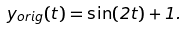<formula> <loc_0><loc_0><loc_500><loc_500>y _ { o r i g } ( t ) = \sin ( 2 t ) + 1 .</formula> 